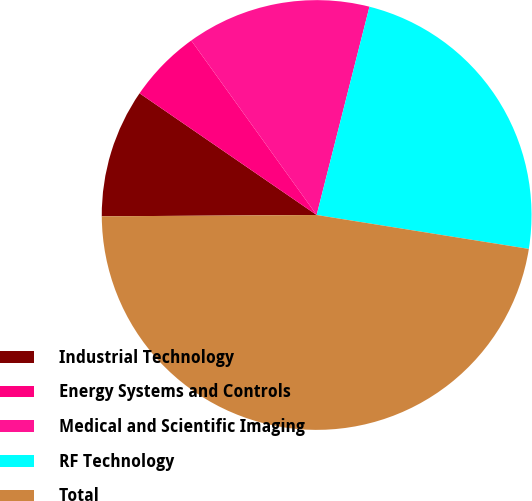Convert chart to OTSL. <chart><loc_0><loc_0><loc_500><loc_500><pie_chart><fcel>Industrial Technology<fcel>Energy Systems and Controls<fcel>Medical and Scientific Imaging<fcel>RF Technology<fcel>Total<nl><fcel>9.68%<fcel>5.5%<fcel>13.87%<fcel>23.57%<fcel>47.38%<nl></chart> 